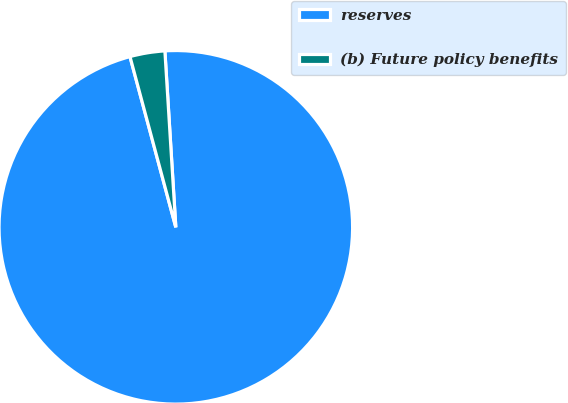Convert chart. <chart><loc_0><loc_0><loc_500><loc_500><pie_chart><fcel>reserves<fcel>(b) Future policy benefits<nl><fcel>96.81%<fcel>3.19%<nl></chart> 